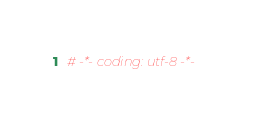Convert code to text. <code><loc_0><loc_0><loc_500><loc_500><_Python_># -*- coding: utf-8 -*-</code> 